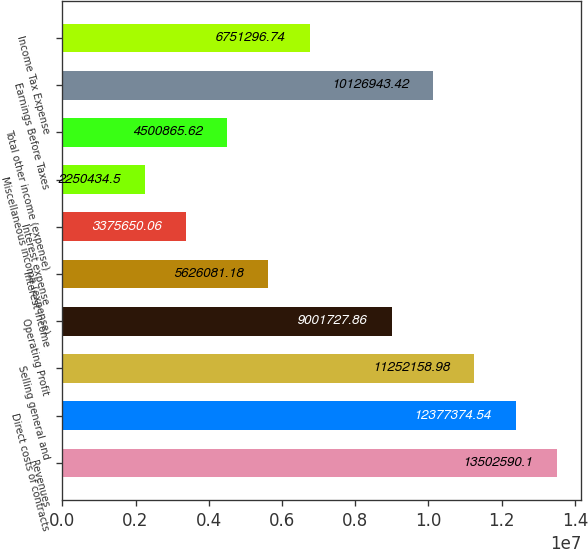Convert chart to OTSL. <chart><loc_0><loc_0><loc_500><loc_500><bar_chart><fcel>Revenues<fcel>Direct costs of contracts<fcel>Selling general and<fcel>Operating Profit<fcel>Interest income<fcel>Interest expense<fcel>Miscellaneous income (expense)<fcel>Total other income (expense)<fcel>Earnings Before Taxes<fcel>Income Tax Expense<nl><fcel>1.35026e+07<fcel>1.23774e+07<fcel>1.12522e+07<fcel>9.00173e+06<fcel>5.62608e+06<fcel>3.37565e+06<fcel>2.25043e+06<fcel>4.50087e+06<fcel>1.01269e+07<fcel>6.7513e+06<nl></chart> 